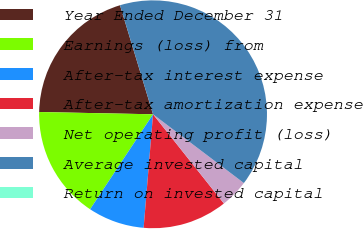Convert chart. <chart><loc_0><loc_0><loc_500><loc_500><pie_chart><fcel>Year Ended December 31<fcel>Earnings (loss) from<fcel>After-tax interest expense<fcel>After-tax amortization expense<fcel>Net operating profit (loss)<fcel>Average invested capital<fcel>Return on invested capital<nl><fcel>20.0%<fcel>16.0%<fcel>8.0%<fcel>12.0%<fcel>4.0%<fcel>40.0%<fcel>0.0%<nl></chart> 